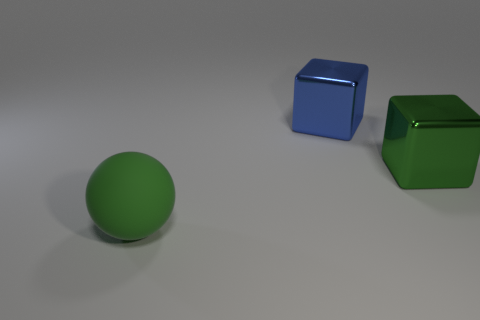Subtract all yellow cubes. Subtract all yellow cylinders. How many cubes are left? 2 Add 3 big blue metallic objects. How many objects exist? 6 Subtract all blocks. How many objects are left? 1 Subtract all small red metal cubes. Subtract all large green balls. How many objects are left? 2 Add 3 large cubes. How many large cubes are left? 5 Add 1 red matte blocks. How many red matte blocks exist? 1 Subtract 0 blue cylinders. How many objects are left? 3 